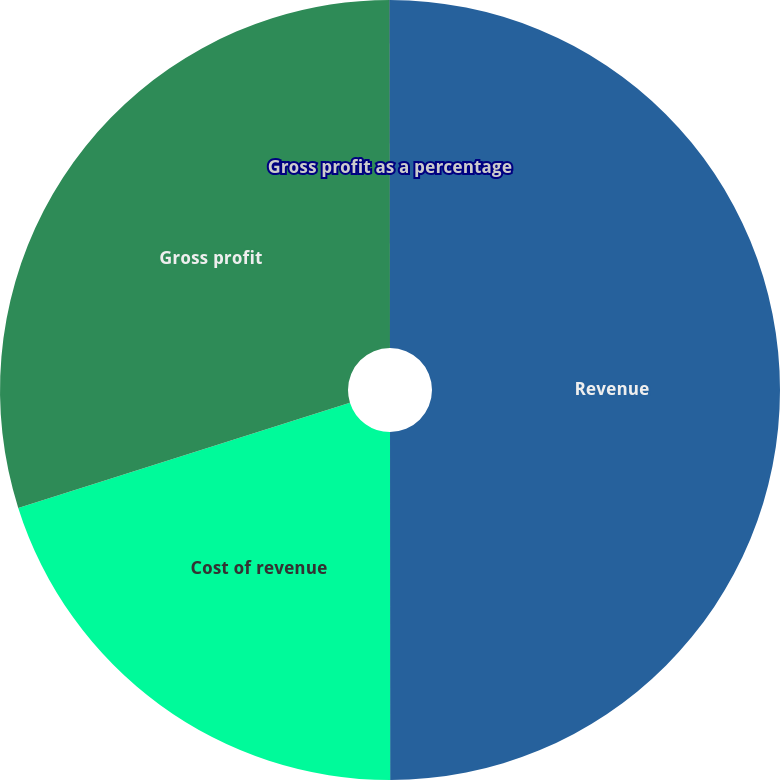<chart> <loc_0><loc_0><loc_500><loc_500><pie_chart><fcel>Revenue<fcel>Cost of revenue<fcel>Gross profit<fcel>Gross profit as a percentage<nl><fcel>50.0%<fcel>20.12%<fcel>29.88%<fcel>0.01%<nl></chart> 